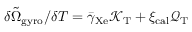Convert formula to latex. <formula><loc_0><loc_0><loc_500><loc_500>\delta \tilde { \Omega } _ { g y r o } / { \delta T } = \bar { \gamma } _ { X e } \mathcal { K } _ { T } + \xi _ { c a l } \mathcal { Q } _ { T }</formula> 